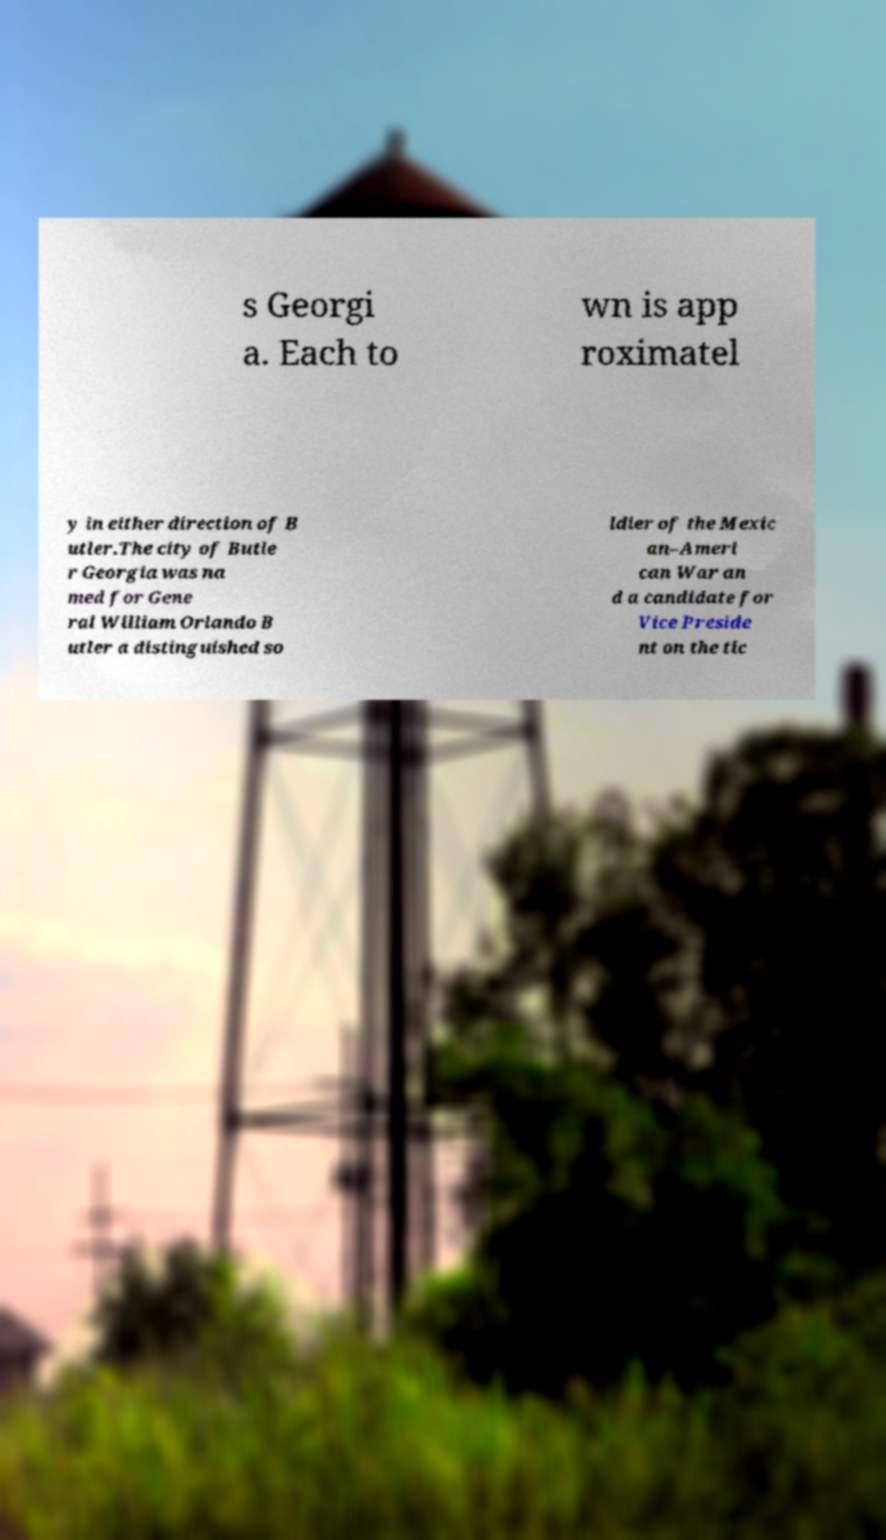Please identify and transcribe the text found in this image. s Georgi a. Each to wn is app roximatel y in either direction of B utler.The city of Butle r Georgia was na med for Gene ral William Orlando B utler a distinguished so ldier of the Mexic an–Ameri can War an d a candidate for Vice Preside nt on the tic 